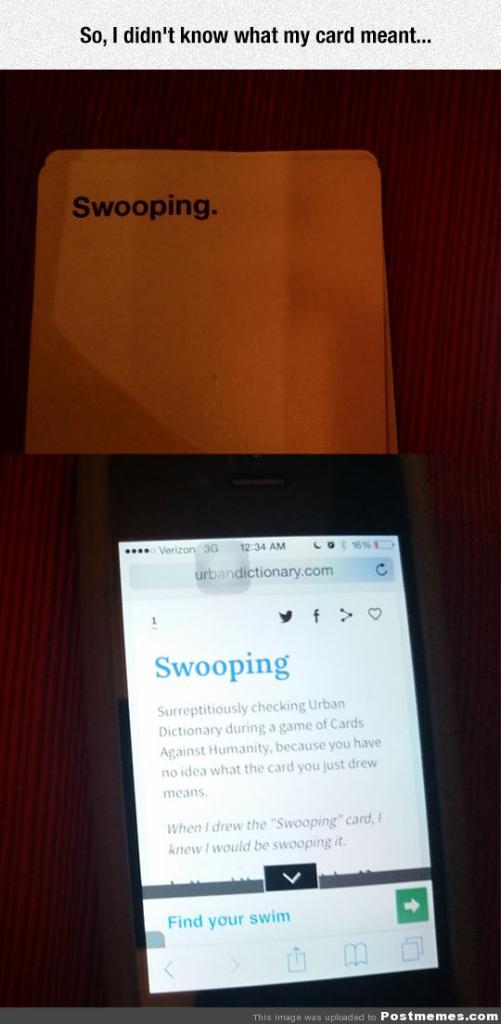What is the title on the phone screen?
Provide a short and direct response. Swooping. 